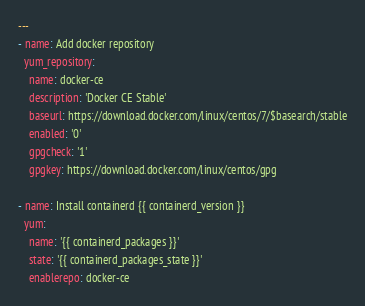Convert code to text. <code><loc_0><loc_0><loc_500><loc_500><_YAML_>---
- name: Add docker repository
  yum_repository:
    name: docker-ce
    description: 'Docker CE Stable'
    baseurl: https://download.docker.com/linux/centos/7/$basearch/stable
    enabled: '0'
    gpgcheck: '1'
    gpgkey: https://download.docker.com/linux/centos/gpg

- name: Install containerd {{ containerd_version }}
  yum:
    name: '{{ containerd_packages }}'
    state: '{{ containerd_packages_state }}'
    enablerepo: docker-ce</code> 